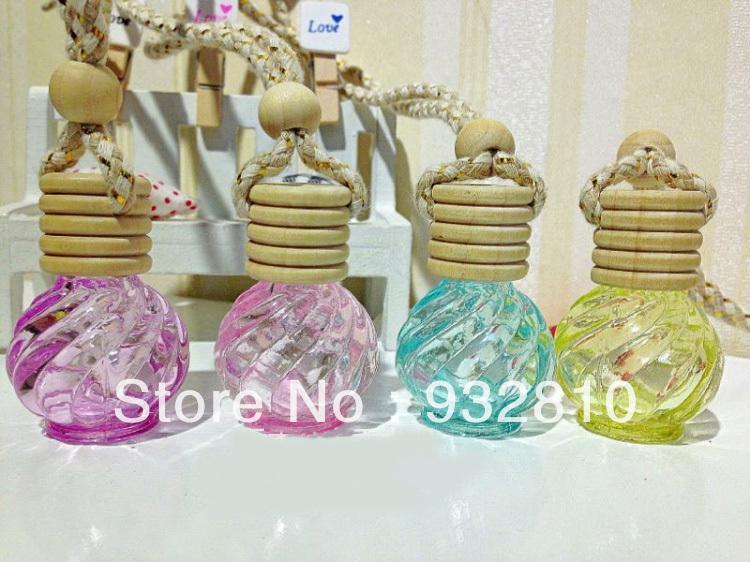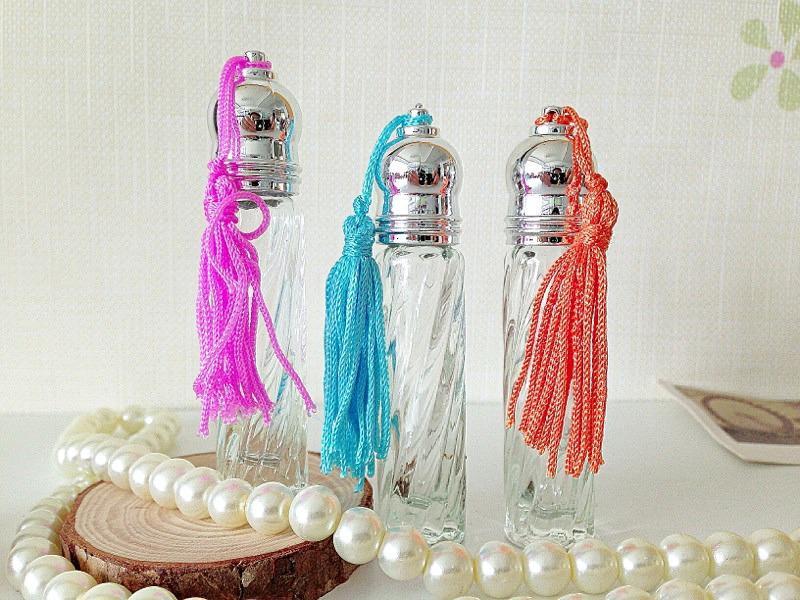The first image is the image on the left, the second image is the image on the right. For the images displayed, is the sentence "One of the images includes a string of pearls on the table." factually correct? Answer yes or no. Yes. The first image is the image on the left, the second image is the image on the right. Assess this claim about the two images: "Pink flowers with green leaves flank a total of three fragrance bottles in the combined images, and at least one fragrance bottle has a clear faceted top shaped like a water drop.". Correct or not? Answer yes or no. No. 